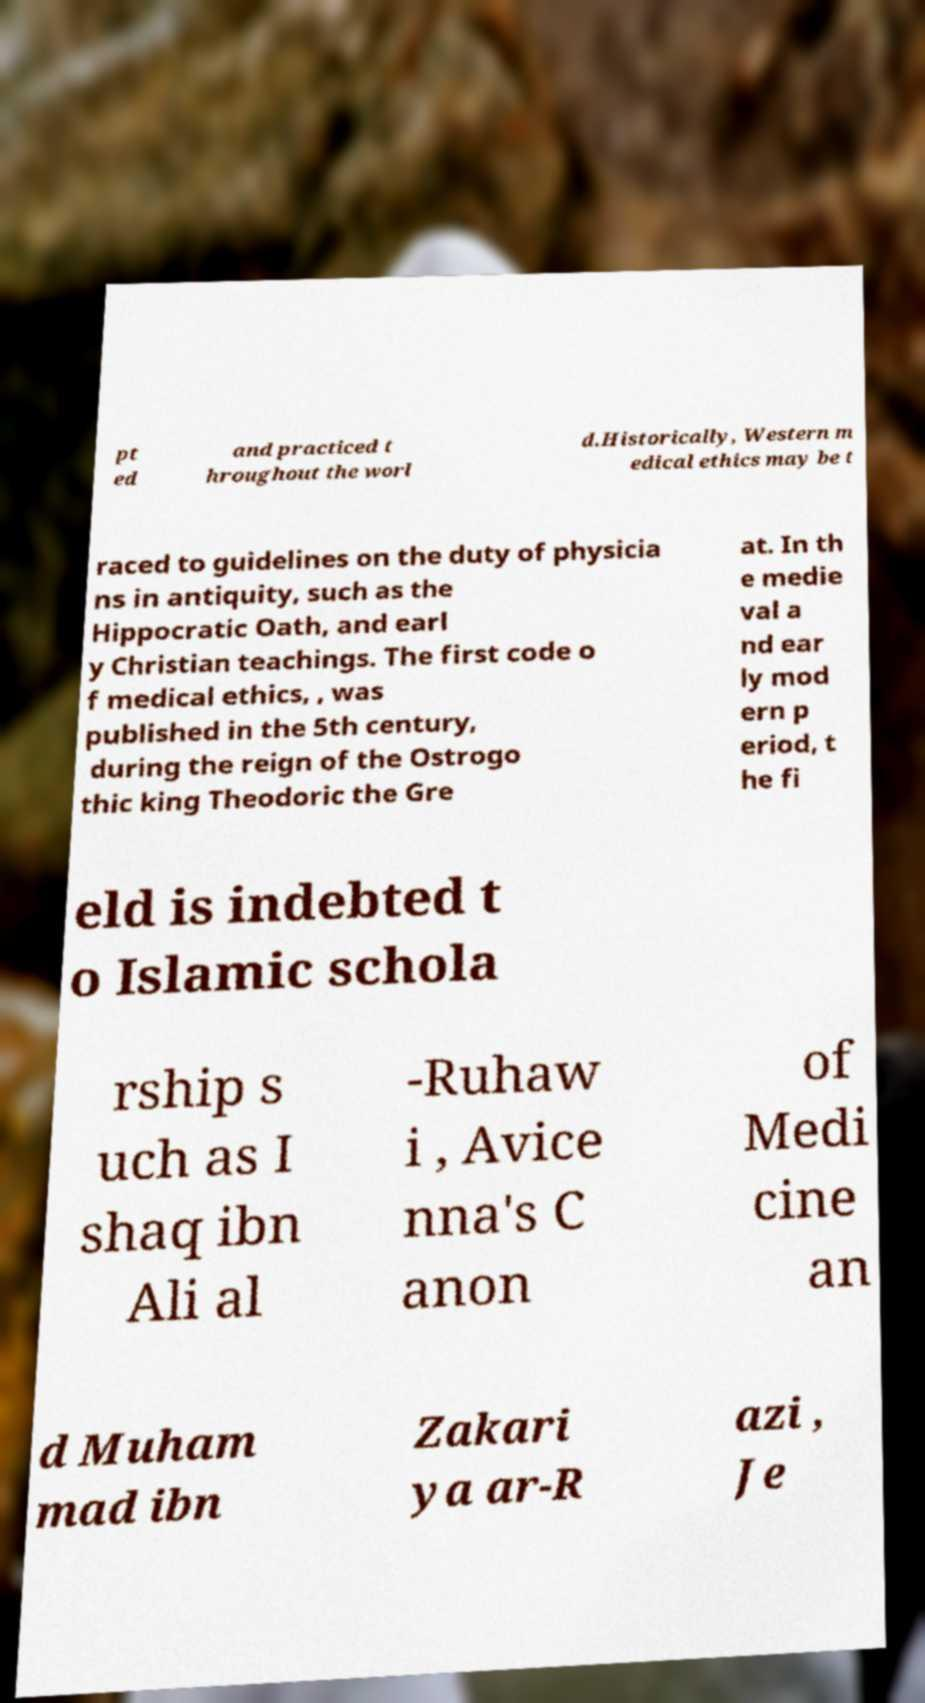Please read and relay the text visible in this image. What does it say? pt ed and practiced t hroughout the worl d.Historically, Western m edical ethics may be t raced to guidelines on the duty of physicia ns in antiquity, such as the Hippocratic Oath, and earl y Christian teachings. The first code o f medical ethics, , was published in the 5th century, during the reign of the Ostrogo thic king Theodoric the Gre at. In th e medie val a nd ear ly mod ern p eriod, t he fi eld is indebted t o Islamic schola rship s uch as I shaq ibn Ali al -Ruhaw i , Avice nna's C anon of Medi cine an d Muham mad ibn Zakari ya ar-R azi , Je 